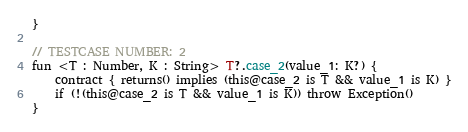<code> <loc_0><loc_0><loc_500><loc_500><_Kotlin_>}

// TESTCASE NUMBER: 2
fun <T : Number, K : String> T?.case_2(value_1: K?) {
    contract { returns() implies (this@case_2 is T && value_1 is K) }
    if (!(this@case_2 is T && value_1 is K)) throw Exception()
}
</code> 